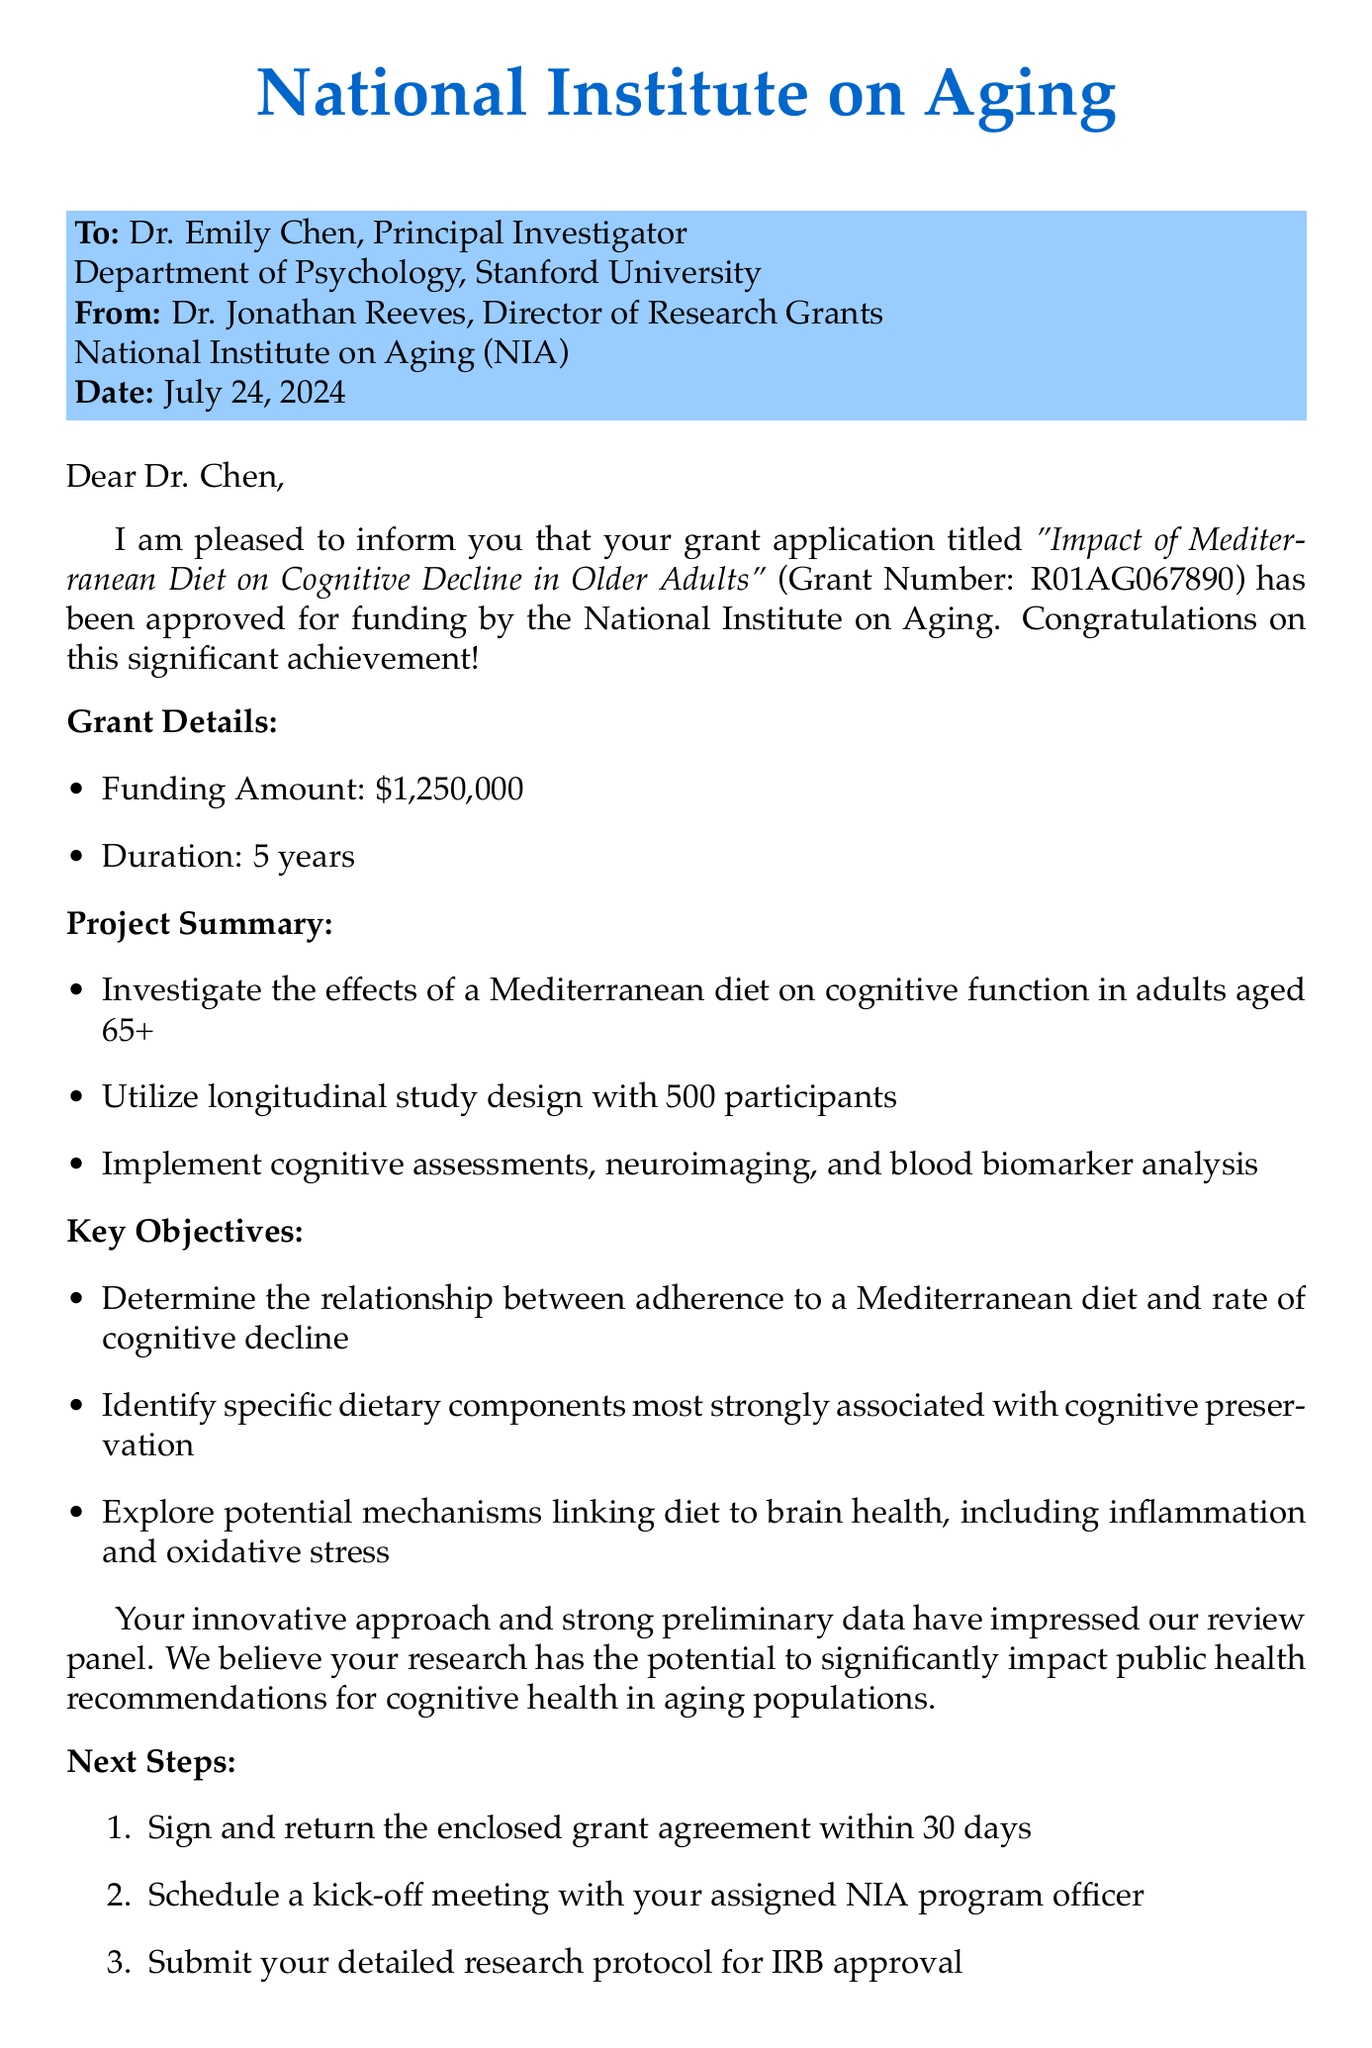What is the title of the grant? The title of the grant is explicitly stated in the document as "Impact of Mediterranean Diet on Cognitive Decline in Older Adults."
Answer: Impact of Mediterranean Diet on Cognitive Decline in Older Adults Who is the Principal Investigator? The document states that Dr. Emily Chen is the Principal Investigator of the grant.
Answer: Dr. Emily Chen What is the funding amount? The funding amount is clearly indicated in the document as $1,250,000.
Answer: $1,250,000 What is the duration of the grant? The duration of the grant is mentioned in the document as 5 years.
Answer: 5 years How many participants will be involved in the study? The document specifies that the study will involve 500 participants.
Answer: 500 participants What relationship does the grant aim to determine? The grant aims to determine the relationship between adherence to a Mediterranean diet and the rate of cognitive decline, as stated in the key objectives.
Answer: Adherence to a Mediterranean diet and rate of cognitive decline What must be submitted for IRB approval? The document notes that the detailed research protocol must be submitted for IRB approval.
Answer: Detailed research protocol What does the congratulatory message highlight? The congratulatory message highlights the impressive innovative approach and strong preliminary data of the research proposal.
Answer: Innovative approach and strong preliminary data What is the grant number? The document clearly states the grant number as R01AG067890.
Answer: R01AG067890 